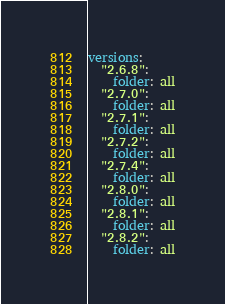<code> <loc_0><loc_0><loc_500><loc_500><_YAML_>versions:
  "2.6.8":
    folder: all
  "2.7.0":
    folder: all
  "2.7.1":
    folder: all
  "2.7.2":
    folder: all
  "2.7.4":
    folder: all
  "2.8.0":
    folder: all
  "2.8.1":
    folder: all
  "2.8.2":
    folder: all
</code> 